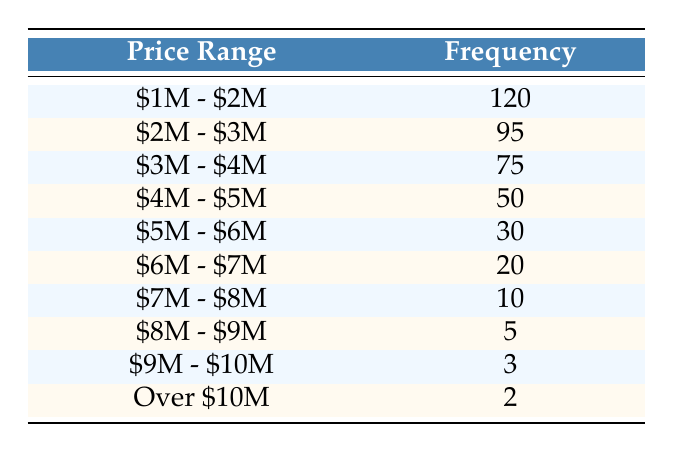What is the frequency of sales in the price range $2M - $3M? The table lists the frequency for each price range, and for the price range $2M - $3M, the frequency is directly stated as 95.
Answer: 95 How many sales were made in the price range of $1M - $2M? In the table, the frequency for the price range $1M - $2M is listed as 120.
Answer: 120 Which price range had the lowest frequency of sales? By inspecting the frequencies in the table, the price range that shows the lowest frequency is 'Over $10M,' with a frequency of 2.
Answer: Over $10M What is the total number of sales across all price ranges? To find the total, we sum the frequencies: (120 + 95 + 75 + 50 + 30 + 20 + 10 + 5 + 3 + 2) = 410.
Answer: 410 Is it true that there were more sales in the $1M - $2M range than in the $5M - $6M range? Comparing the frequencies, $1M - $2M has 120 sales and $5M - $6M has 30 sales. Since 120 is greater than 30, the statement is true.
Answer: Yes What is the average frequency of sales for the price ranges above $5M? The sales frequencies for ranges above $5M are 30 ($5M - $6M), 20 ($6M - $7M), 10 ($7M - $8M), 5 ($8M - $9M), 3 ($9M - $10M), and 2 (Over $10M). Summing these gives (30 + 20 + 10 + 5 + 3 + 2) = 70. There are 6 price ranges, so the average is 70/6 ≈ 11.67.
Answer: 11.67 What is the difference in frequency between the $3M - $4M range and the $4M - $5M range? The frequency for $3M - $4M is 75, and for $4M - $5M it is 50. Calculating the difference gives 75 - 50 = 25.
Answer: 25 How many more sales were made in the $1M - $2M range compared to the $6M - $7M range? The frequency for $1M - $2M is 120, while for $6M - $7M it is 20. The difference is 120 - 20 = 100.
Answer: 100 Did the frequency of sales decrease consistently across price ranges? Examining the frequencies in the table, it shows 120, 95, 75, 50, 30, 20, 10, 5, 3, 2. The numbers do indeed decrease with each price range, confirming consistent decline.
Answer: Yes 